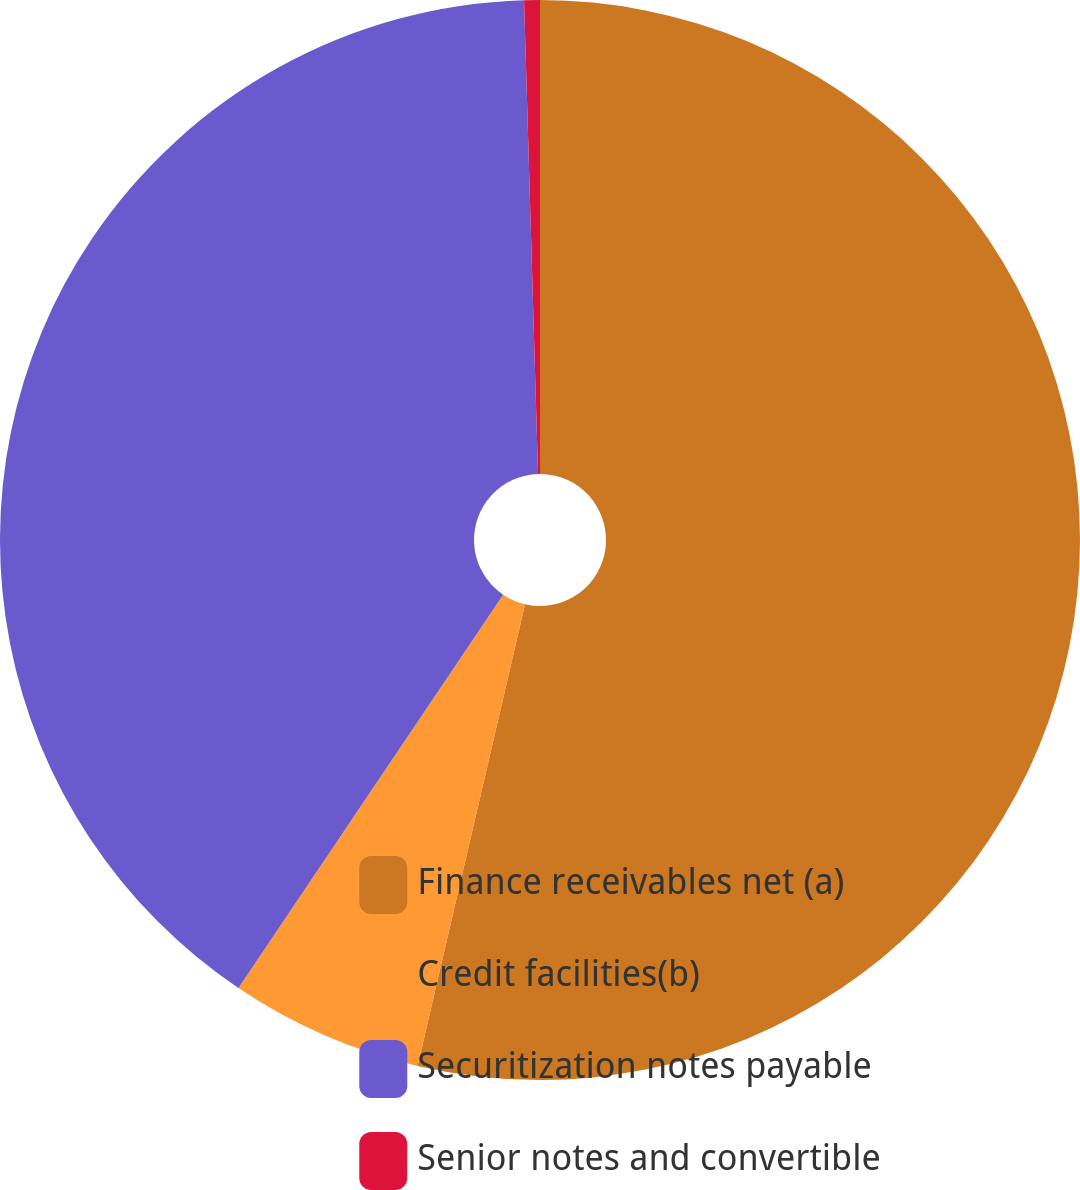Convert chart. <chart><loc_0><loc_0><loc_500><loc_500><pie_chart><fcel>Finance receivables net (a)<fcel>Credit facilities(b)<fcel>Securitization notes payable<fcel>Senior notes and convertible<nl><fcel>53.64%<fcel>5.79%<fcel>40.1%<fcel>0.47%<nl></chart> 